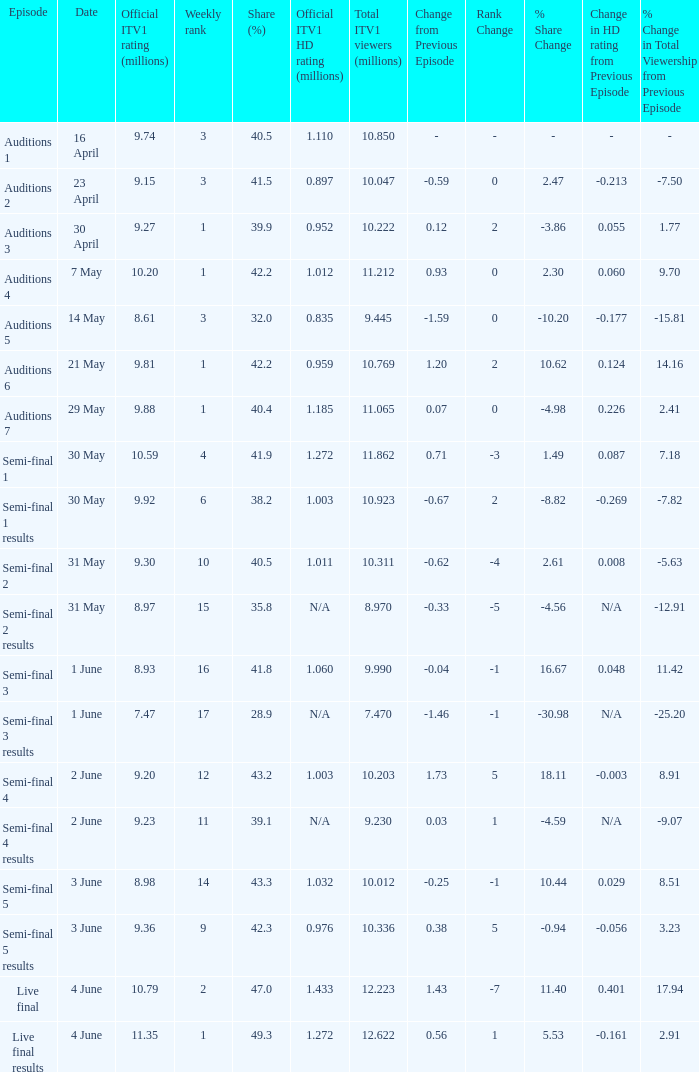What was the official ITV1 HD rating in millions for the episode that had an official ITV1 rating of 8.98 million? 1.032. 